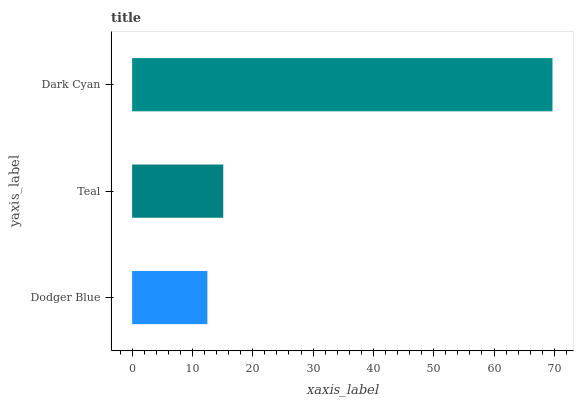Is Dodger Blue the minimum?
Answer yes or no. Yes. Is Dark Cyan the maximum?
Answer yes or no. Yes. Is Teal the minimum?
Answer yes or no. No. Is Teal the maximum?
Answer yes or no. No. Is Teal greater than Dodger Blue?
Answer yes or no. Yes. Is Dodger Blue less than Teal?
Answer yes or no. Yes. Is Dodger Blue greater than Teal?
Answer yes or no. No. Is Teal less than Dodger Blue?
Answer yes or no. No. Is Teal the high median?
Answer yes or no. Yes. Is Teal the low median?
Answer yes or no. Yes. Is Dark Cyan the high median?
Answer yes or no. No. Is Dark Cyan the low median?
Answer yes or no. No. 